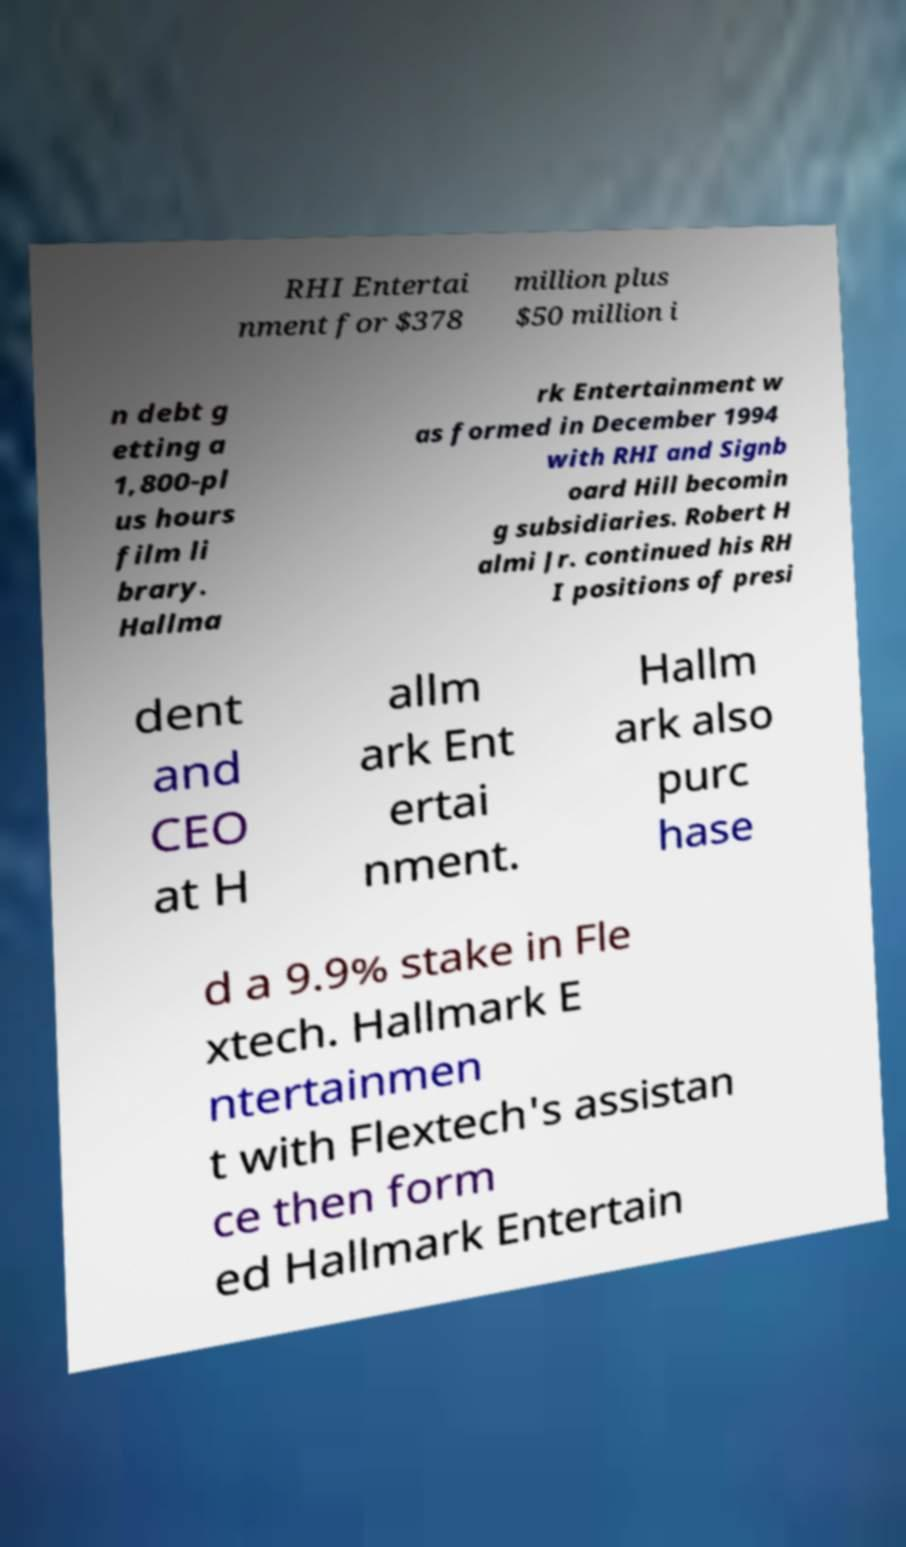Could you assist in decoding the text presented in this image and type it out clearly? RHI Entertai nment for $378 million plus $50 million i n debt g etting a 1,800-pl us hours film li brary. Hallma rk Entertainment w as formed in December 1994 with RHI and Signb oard Hill becomin g subsidiaries. Robert H almi Jr. continued his RH I positions of presi dent and CEO at H allm ark Ent ertai nment. Hallm ark also purc hase d a 9.9% stake in Fle xtech. Hallmark E ntertainmen t with Flextech's assistan ce then form ed Hallmark Entertain 